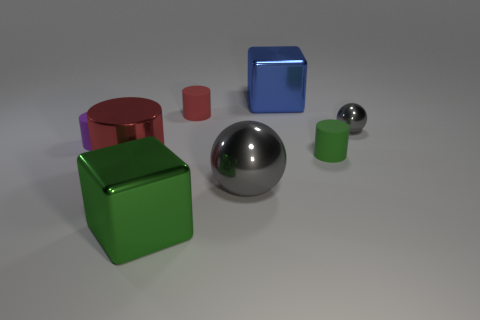There is a object that is both behind the purple matte cylinder and left of the blue shiny cube; what is its size?
Your answer should be very brief. Small. Is the number of small objects behind the tiny purple matte cylinder less than the number of metallic things that are right of the small gray shiny thing?
Ensure brevity in your answer.  No. Does the gray sphere that is on the right side of the blue metallic block have the same material as the gray thing that is in front of the small purple rubber object?
Offer a terse response. Yes. What material is the big ball that is the same color as the small metal ball?
Offer a terse response. Metal. What shape is the big thing that is both on the right side of the small red thing and in front of the purple object?
Offer a very short reply. Sphere. What is the material of the red object that is to the left of the green object on the left side of the blue block?
Make the answer very short. Metal. Is the number of green blocks greater than the number of purple balls?
Your answer should be very brief. Yes. Is the big shiny sphere the same color as the tiny metal thing?
Ensure brevity in your answer.  Yes. There is a green thing that is the same size as the purple cylinder; what material is it?
Keep it short and to the point. Rubber. Is the material of the small green cylinder the same as the small red cylinder?
Offer a very short reply. Yes. 